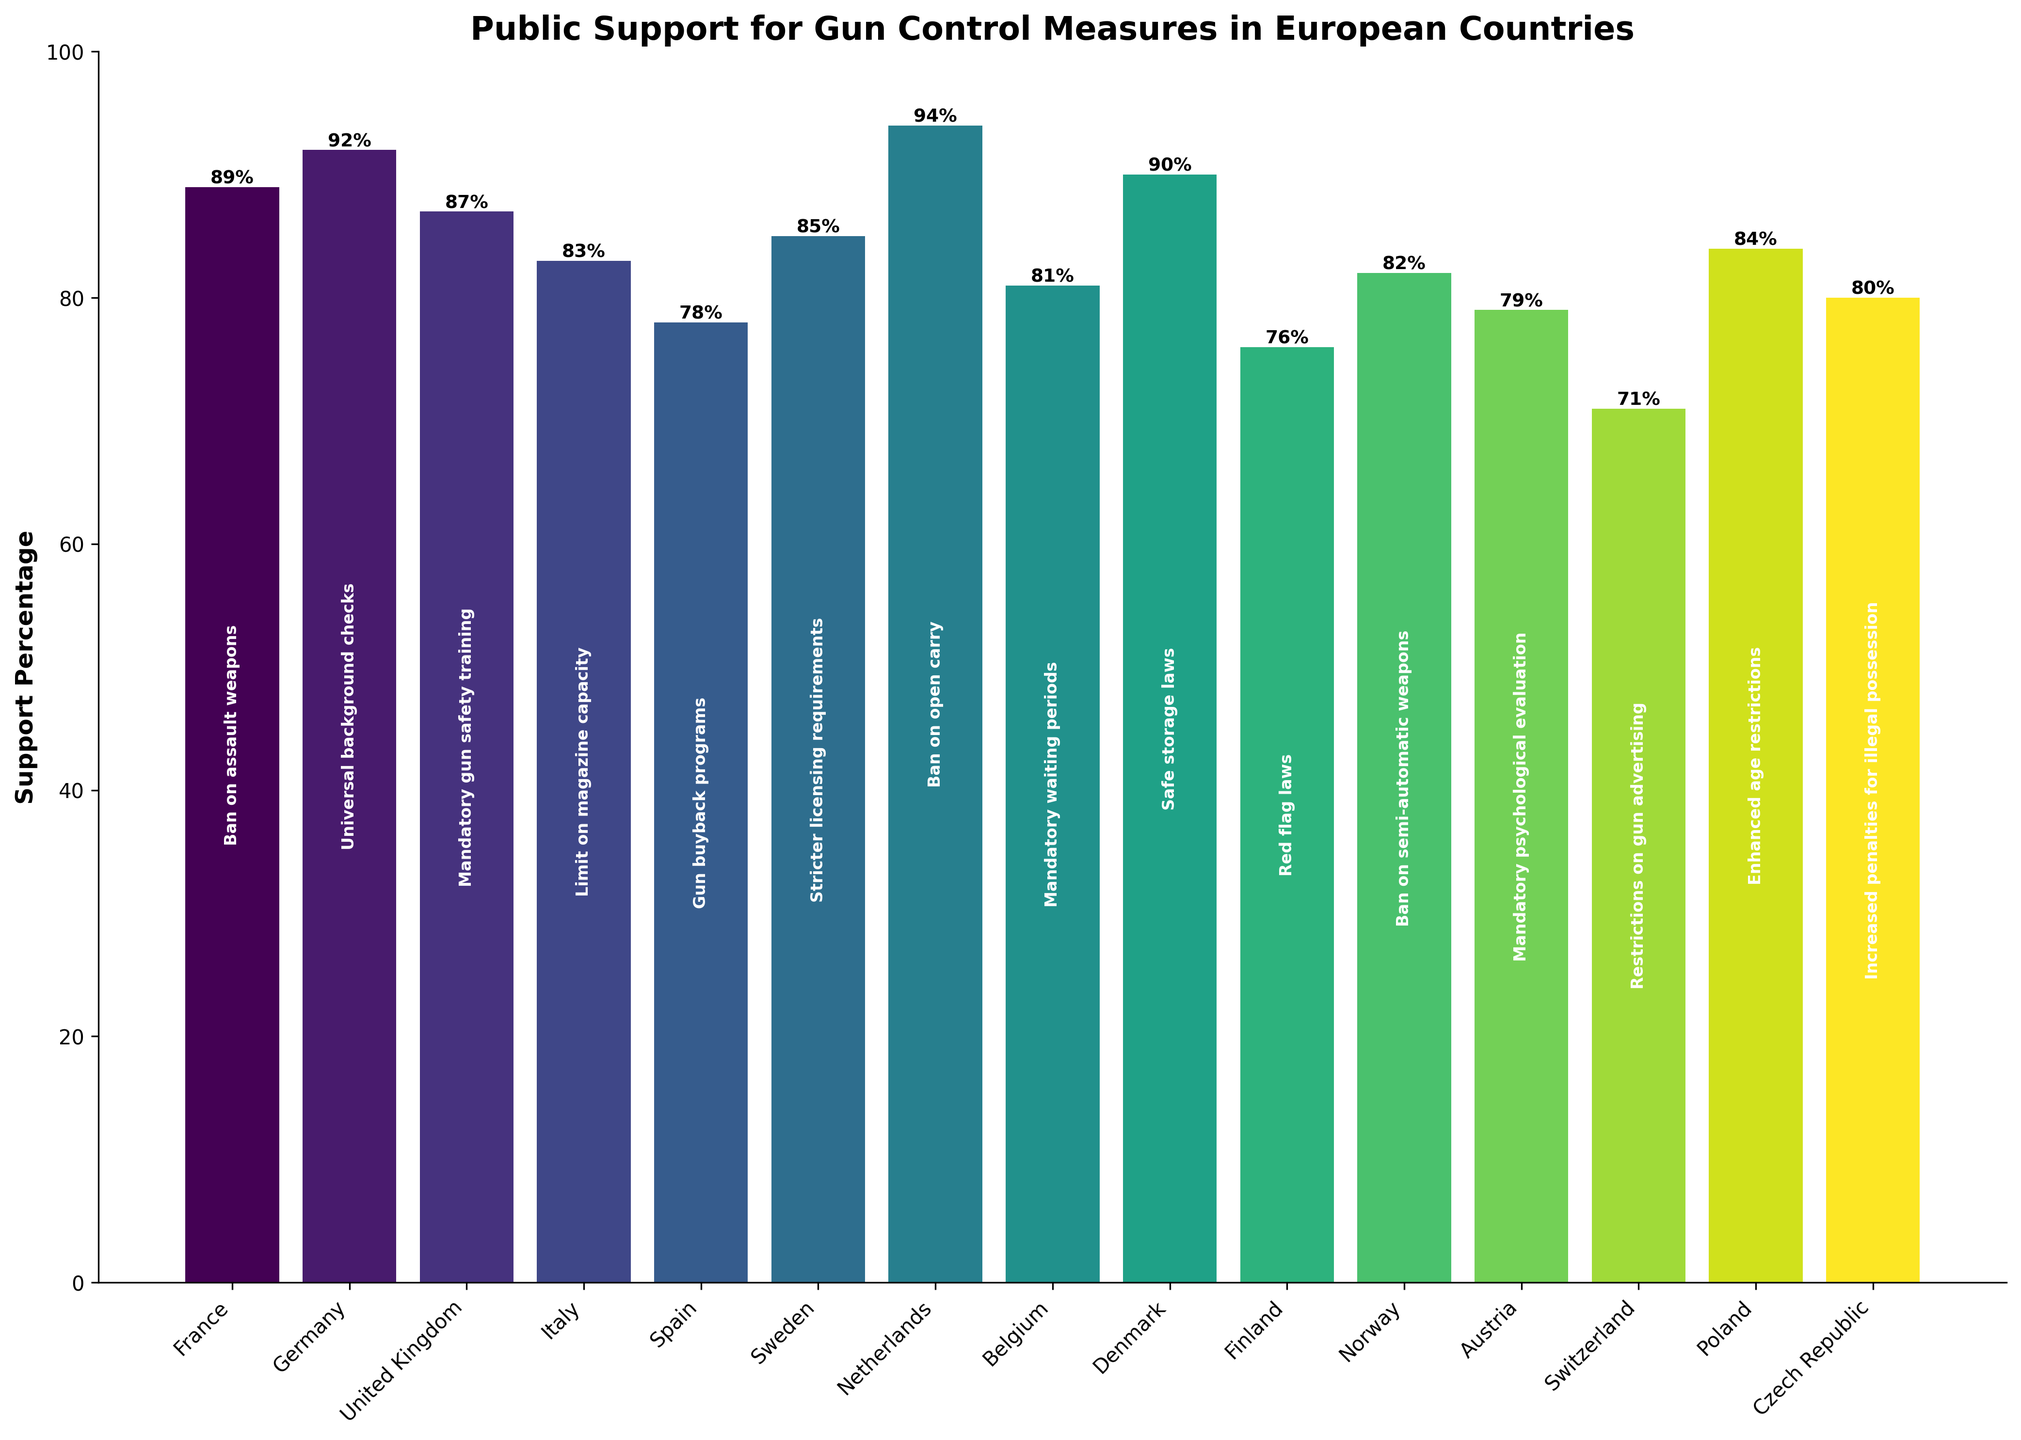What country has the highest support percentage for a gun control measure? The bar for the Netherlands has the highest value at 94%, indicating the highest support for banning open carry among all the countries listed in the figure.
Answer: Netherlands What is the average support percentage for the listed gun control measures across all countries? Sum up all the support percentages: 89+92+87+83+78+85+94+81+90+76+82+79+71+84+80 = 1261. There are 15 countries, so the average is 1261/15 = 84.07.
Answer: 84.07 Which countries have a support percentage lower than 80%? The bars for Spain, Finland, Switzerland, and Austria are below 80%.
Answer: Spain, Finland, Switzerland, Austria By how much does the support for mandatory gun safety training in the United Kingdom exceed its support in Switzerland? The bar for the UK shows 87%, and the bar for Switzerland shows 71%. So, 87% - 71% = 16%.
Answer: 16% If we group the countries into those with above-average support and those with below-average support, which ones fall into each group? The average is 84.07%. Above average: France, Germany, UK, Sweden, Netherlands, Denmark, Poland. Below average: Italy, Spain, Finland, Norway, Austria, Switzerland, Czech Republic, Belgium.
Answer: Above: France, Germany, UK, Sweden, Netherlands, Denmark, Poland. Below: Italy, Spain, Finland, Norway, Austria, Switzerland, Czech Republic, Belgium What is the support percentage for enhanced age restrictions in Poland? The bar for Poland indicates a value of 84%.
Answer: 84% Which country has the closest support percentage to 85% and what measure does this correspond to? Sweden is closest with a support percentage of 85% for stricter licensing requirements.
Answer: Sweden, stricter licensing requirements How does the support percentage for a ban on assault weapons in France compare to the support for a gun buyback program in Spain? The bar for the ban on assault weapons in France indicates 89%, and the bar for the gun buyback program in Spain shows 78%. Thus, France has higher support by 89% - 78% = 11%.
Answer: France has 11% higher support Which measure has the least support across the listed European countries, and what is the support percentage? The bar for restrictions on gun advertising in Switzerland is the lowest at 71%.
Answer: Restrictions on gun advertising, 71% What is the total support percentage for all gun control measures in Nordic countries (Denmark, Sweden, Finland, Norway)? The support percentages are Denmark: 90%, Sweden: 85%, Finland: 76%, Norway: 82%. The total is 90 + 85 + 76 + 82 = 333.
Answer: 333 